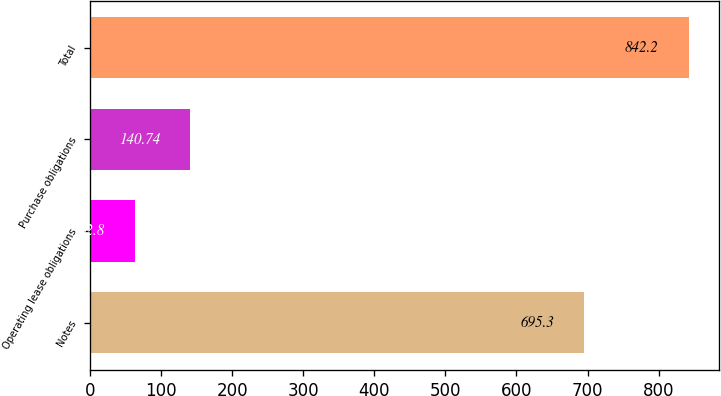<chart> <loc_0><loc_0><loc_500><loc_500><bar_chart><fcel>Notes<fcel>Operating lease obligations<fcel>Purchase obligations<fcel>Total<nl><fcel>695.3<fcel>62.8<fcel>140.74<fcel>842.2<nl></chart> 